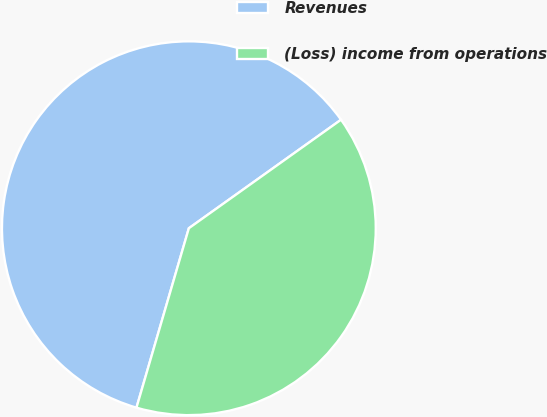Convert chart. <chart><loc_0><loc_0><loc_500><loc_500><pie_chart><fcel>Revenues<fcel>(Loss) income from operations<nl><fcel>60.62%<fcel>39.38%<nl></chart> 